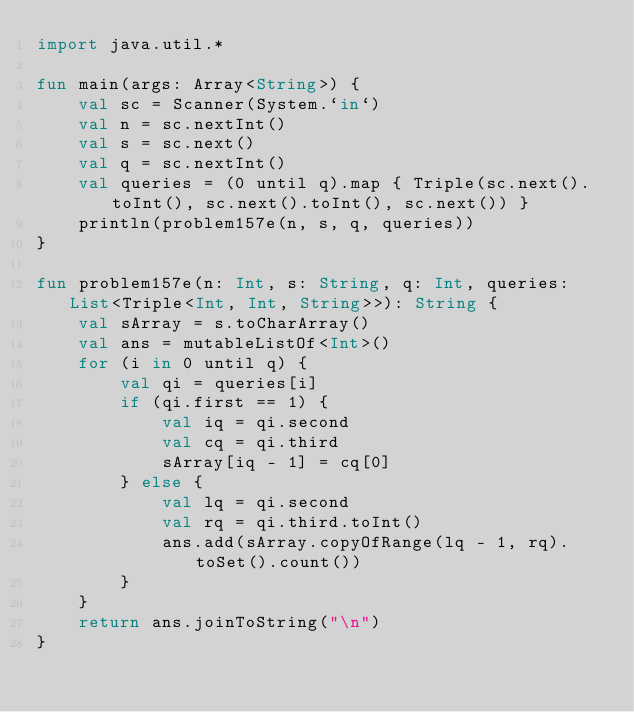Convert code to text. <code><loc_0><loc_0><loc_500><loc_500><_Kotlin_>import java.util.*

fun main(args: Array<String>) {
    val sc = Scanner(System.`in`)
    val n = sc.nextInt()
    val s = sc.next()
    val q = sc.nextInt()
    val queries = (0 until q).map { Triple(sc.next().toInt(), sc.next().toInt(), sc.next()) }
    println(problem157e(n, s, q, queries))
}

fun problem157e(n: Int, s: String, q: Int, queries: List<Triple<Int, Int, String>>): String {
    val sArray = s.toCharArray()
    val ans = mutableListOf<Int>()
    for (i in 0 until q) {
        val qi = queries[i]
        if (qi.first == 1) {
            val iq = qi.second
            val cq = qi.third
            sArray[iq - 1] = cq[0]
        } else {
            val lq = qi.second
            val rq = qi.third.toInt()
            ans.add(sArray.copyOfRange(lq - 1, rq).toSet().count())
        }
    }
    return ans.joinToString("\n")
}</code> 